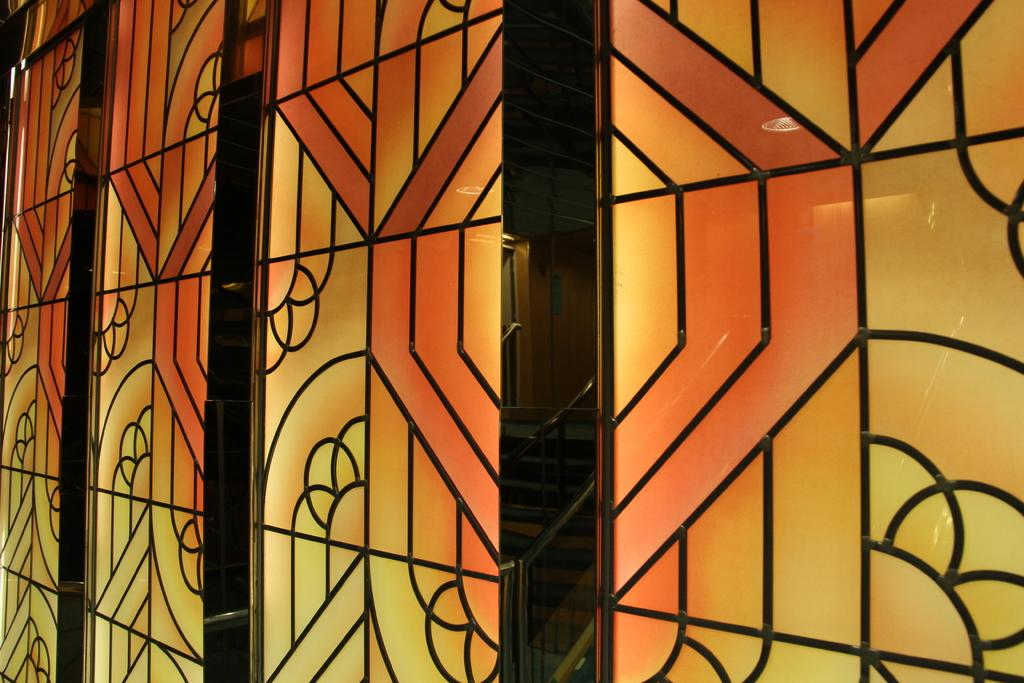What color is the wall in the image? The wall in the image is orange. Are there any other colors present on the wall? Yes, there is yellow color on the wall. What type of wood can be seen on the wall in the image? There is no wood visible on the wall in the image; it is painted with orange and yellow colors. 